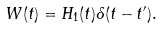<formula> <loc_0><loc_0><loc_500><loc_500>W ( t ) = H _ { 1 } ( t ) \delta ( t - t ^ { \prime } ) .</formula> 